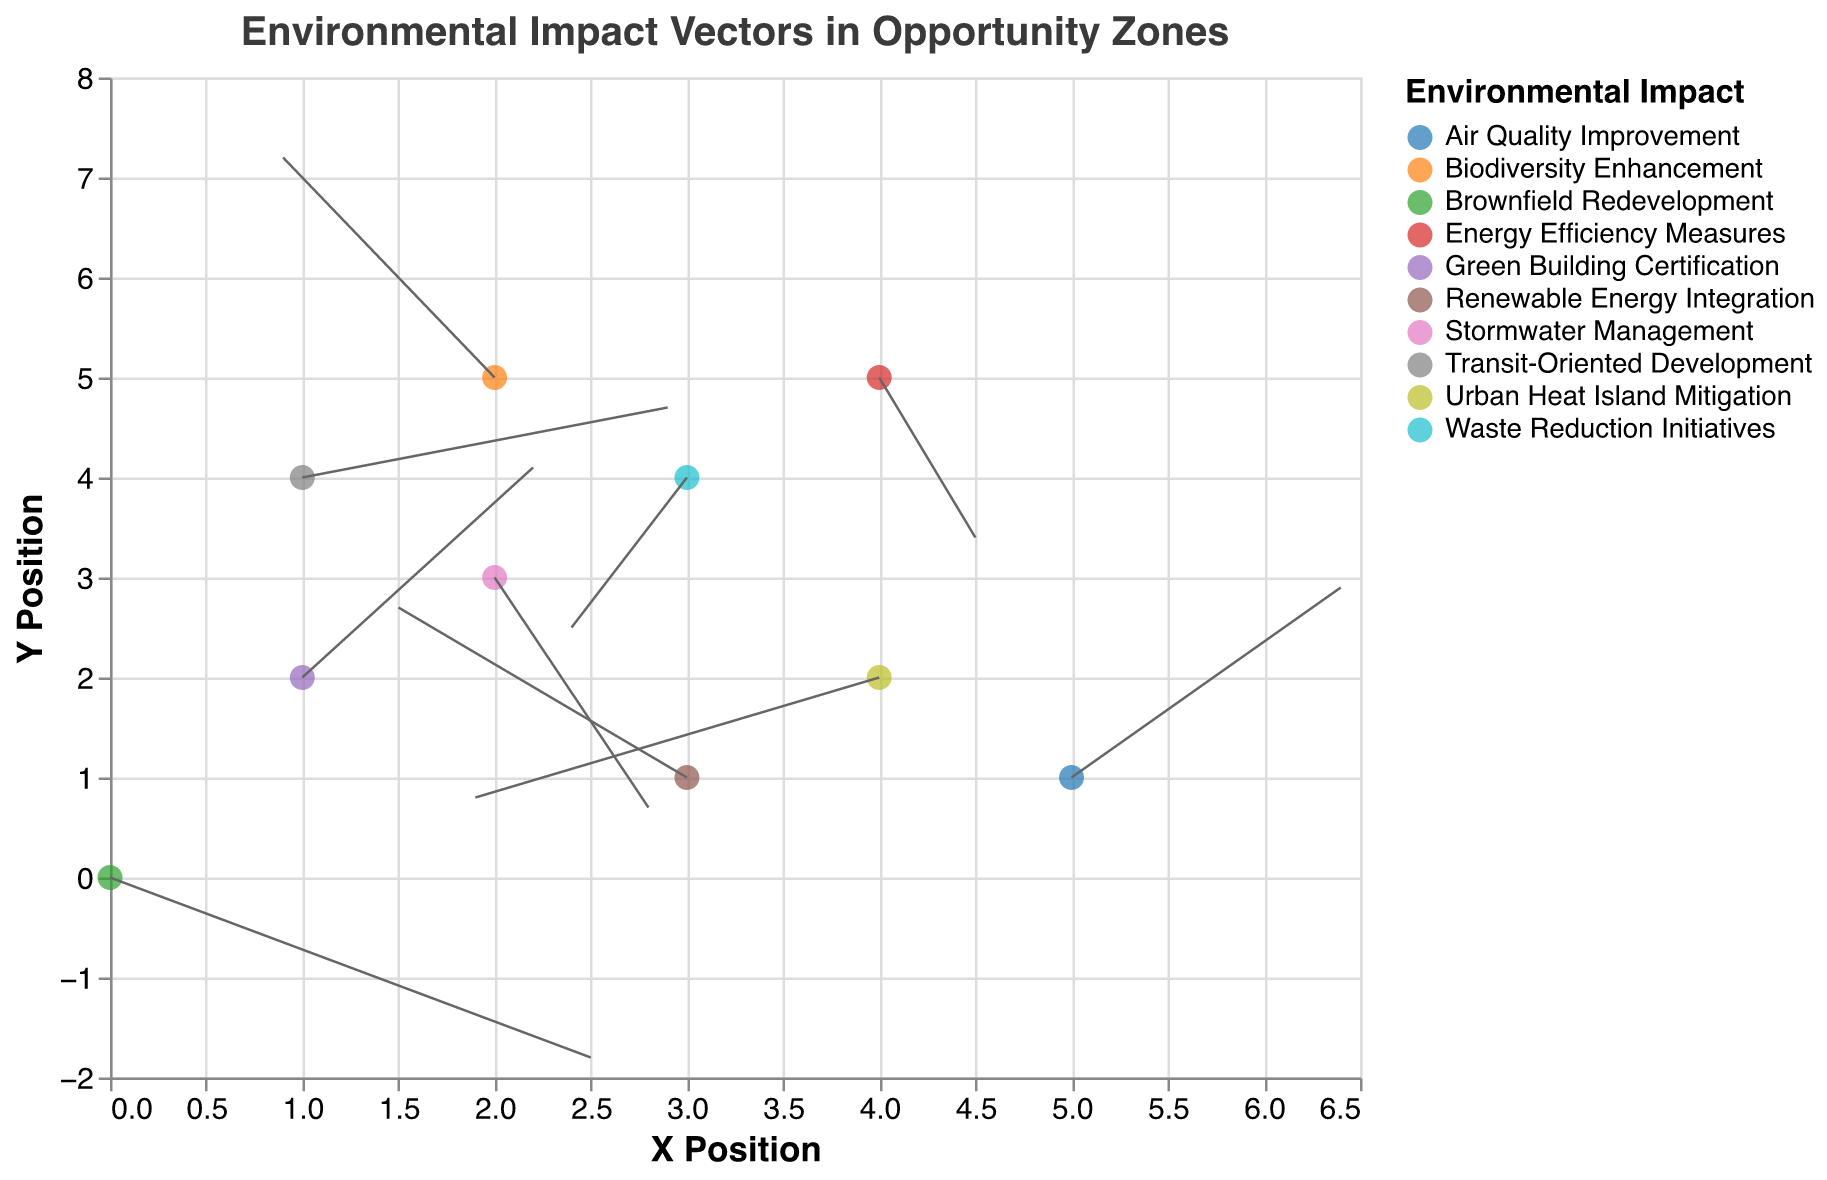What is the title of the figure? The title is located at the top of the figure.
Answer: Environmental Impact Vectors in Opportunity Zones How many distinct environmental impacts are represented in the figure? The legend lists all distinct environmental impacts, each indicated by a different color.
Answer: 10 Which environmental impact has a vector starting from coordinates (1, 2)? By looking at the (1, 2) coordinates and checking the impact associated with it.
Answer: Green Building Certification What are the coordinates where the vector for Urban Heat Island Mitigation ends? The vector starts at (4, 2) with changes (-2.1, -1.2), so the end coordinates are (4-2.1, 2-1.2) = (1.9, 0.8).
Answer: (1.9, 0.8) Which environmental impact shows the greatest increase in the Y-direction? The Y component with the highest positive value is 2.2 for Biodiversity Enhancement.
Answer: Biodiversity Enhancement What is the net change in the X-direction for the vector representing Renewable Energy Integration? The U component for Renewable Energy Integration is -1.5, which means a net change of -1.5 units.
Answer: -1.5 Compare the length of vectors for Brownfield Redevelopment and Energy Efficiency Measures. Which is longer? Calculate the length using sqrt(U^2 + V^2). Brownfield Redevelopment: sqrt(2.5^2 + (-1.8)^2) ≈ 3.02, Energy Efficiency Measures: sqrt(0.5^2 + (-1.6)^2) ≈ 1.67.
Answer: Brownfield Redevelopment Which environmental impact shows a movement downwards and to the left? Downward movement indicates a negative V component, and leftward movement indicates a negative U component. Urban Heat Island Mitigation fits this as U = -2.1 and V = -1.2.
Answer: Urban Heat Island Mitigation What's the average net change in the X-direction for all vectors? Sum all U components (2.5 + 1.2 - 1.5 + 0.8 - 2.1 + 1.9 - 0.6 + 1.4 - 1.1 + 0.5) = 2.9, then divide by 10 data points: 2.9/10 = 0.29.
Answer: 0.29 